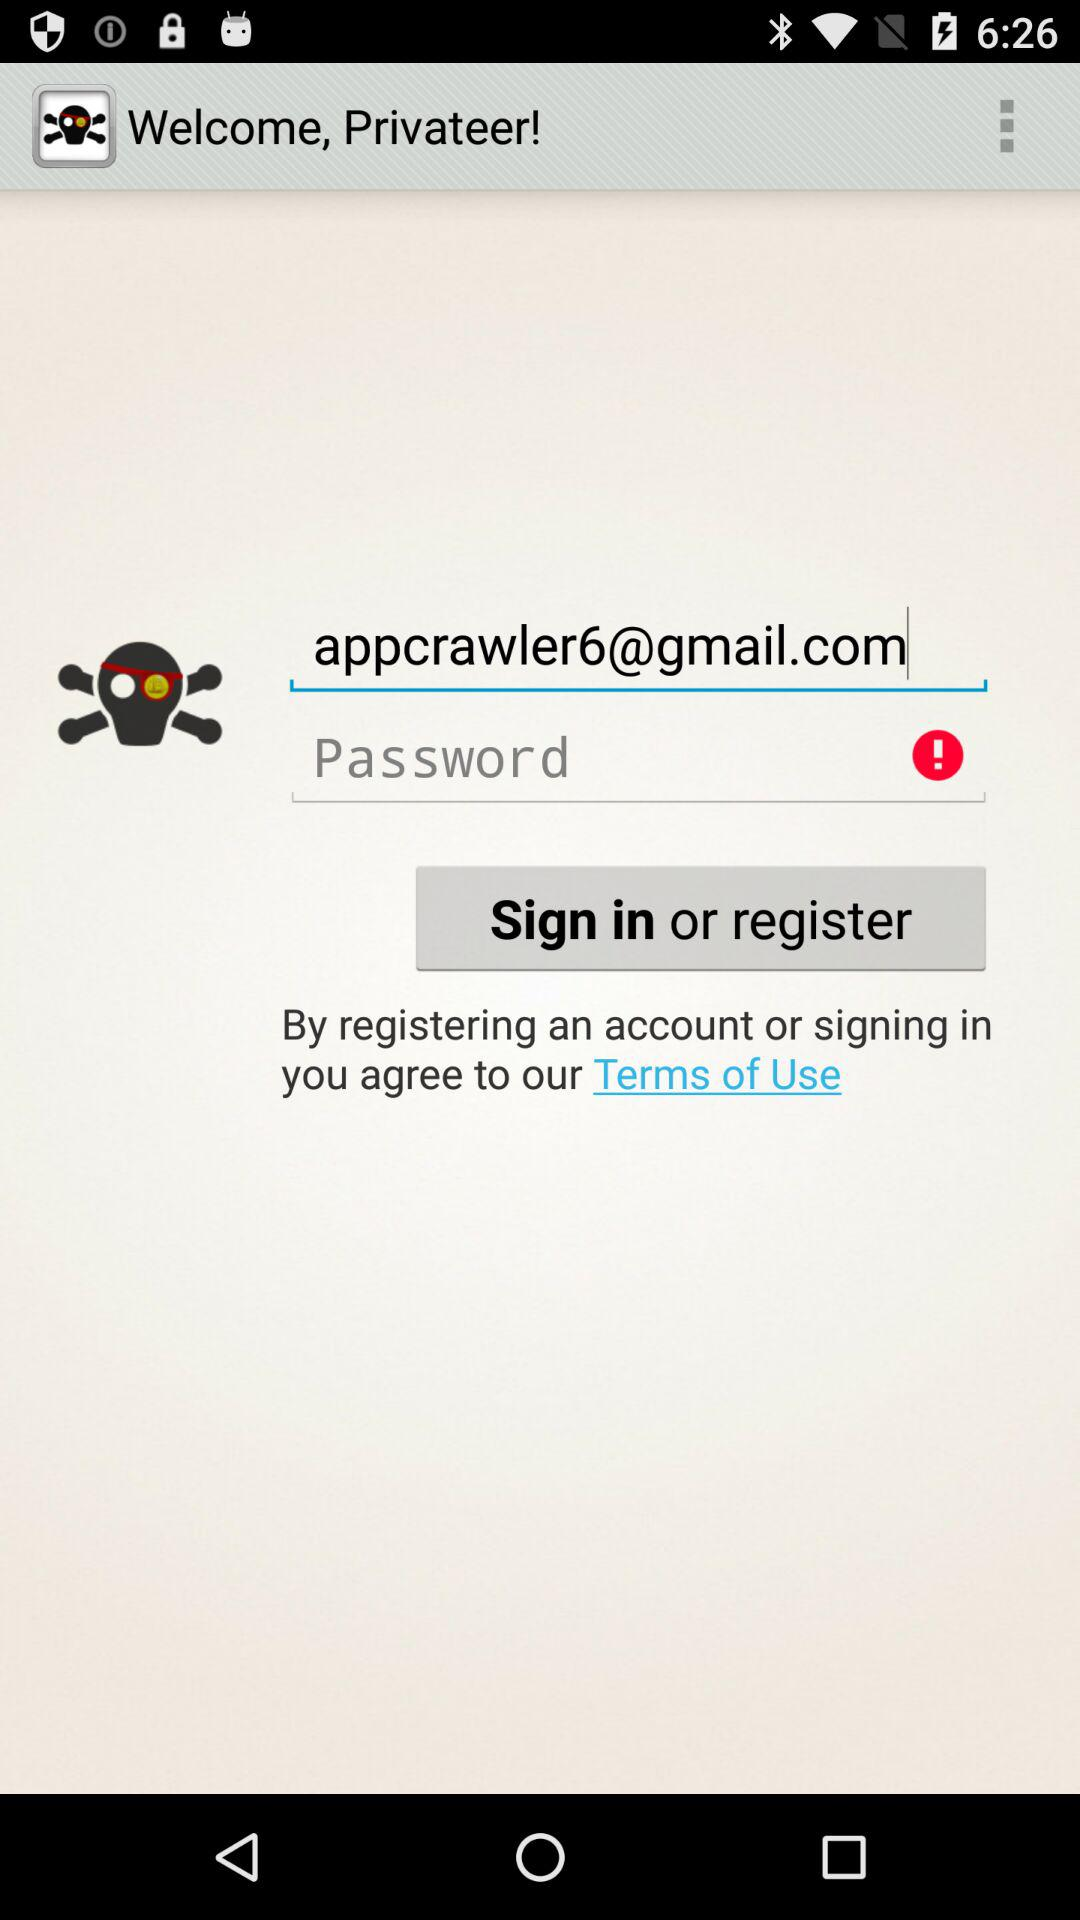What is the email ID of the user to sign in? The email ID is appcrawler6@gmail.com. 